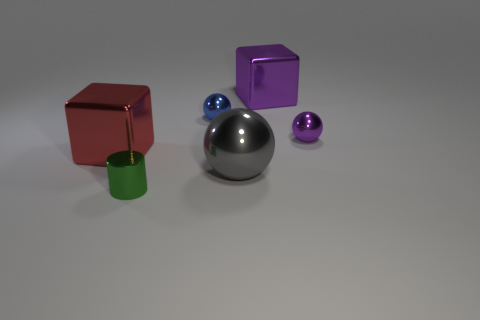Add 2 big purple blocks. How many objects exist? 8 Subtract all red cubes. How many cubes are left? 1 Subtract all small purple metallic spheres. How many spheres are left? 2 Subtract all cylinders. How many objects are left? 5 Subtract all gray cylinders. How many cyan spheres are left? 0 Subtract all gray metallic spheres. Subtract all large matte cubes. How many objects are left? 5 Add 3 metal cylinders. How many metal cylinders are left? 4 Add 6 spheres. How many spheres exist? 9 Subtract 0 cyan spheres. How many objects are left? 6 Subtract 1 blocks. How many blocks are left? 1 